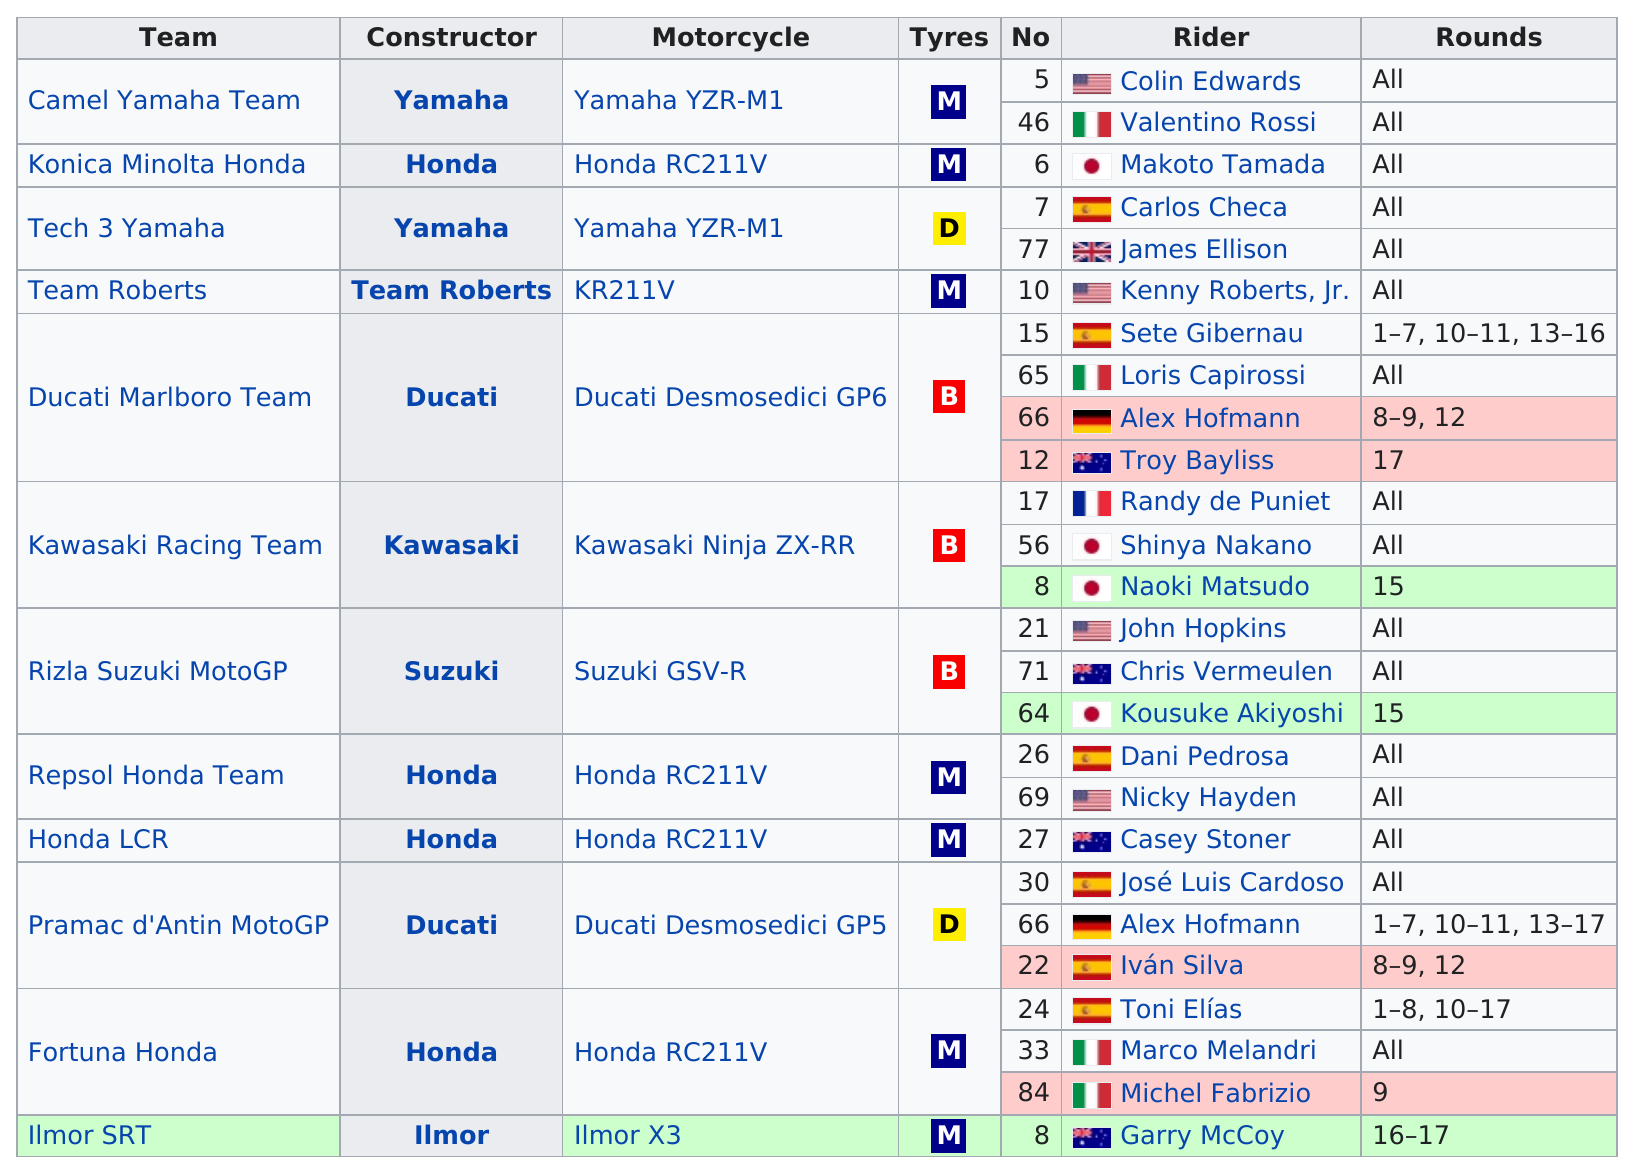Point out several critical features in this image. The Ducati Marlboro Team was the team that was the largest among the others. Garry McCoy rode a motorcycle named Ilmor X3 as part of his racing team. The name of the last rider on this chart is Garry McCoy. There are 7 instances of the letter 'm' that appear under the 'tyres' column. The Camel Yamaha Team is the first team listed on this chart. 